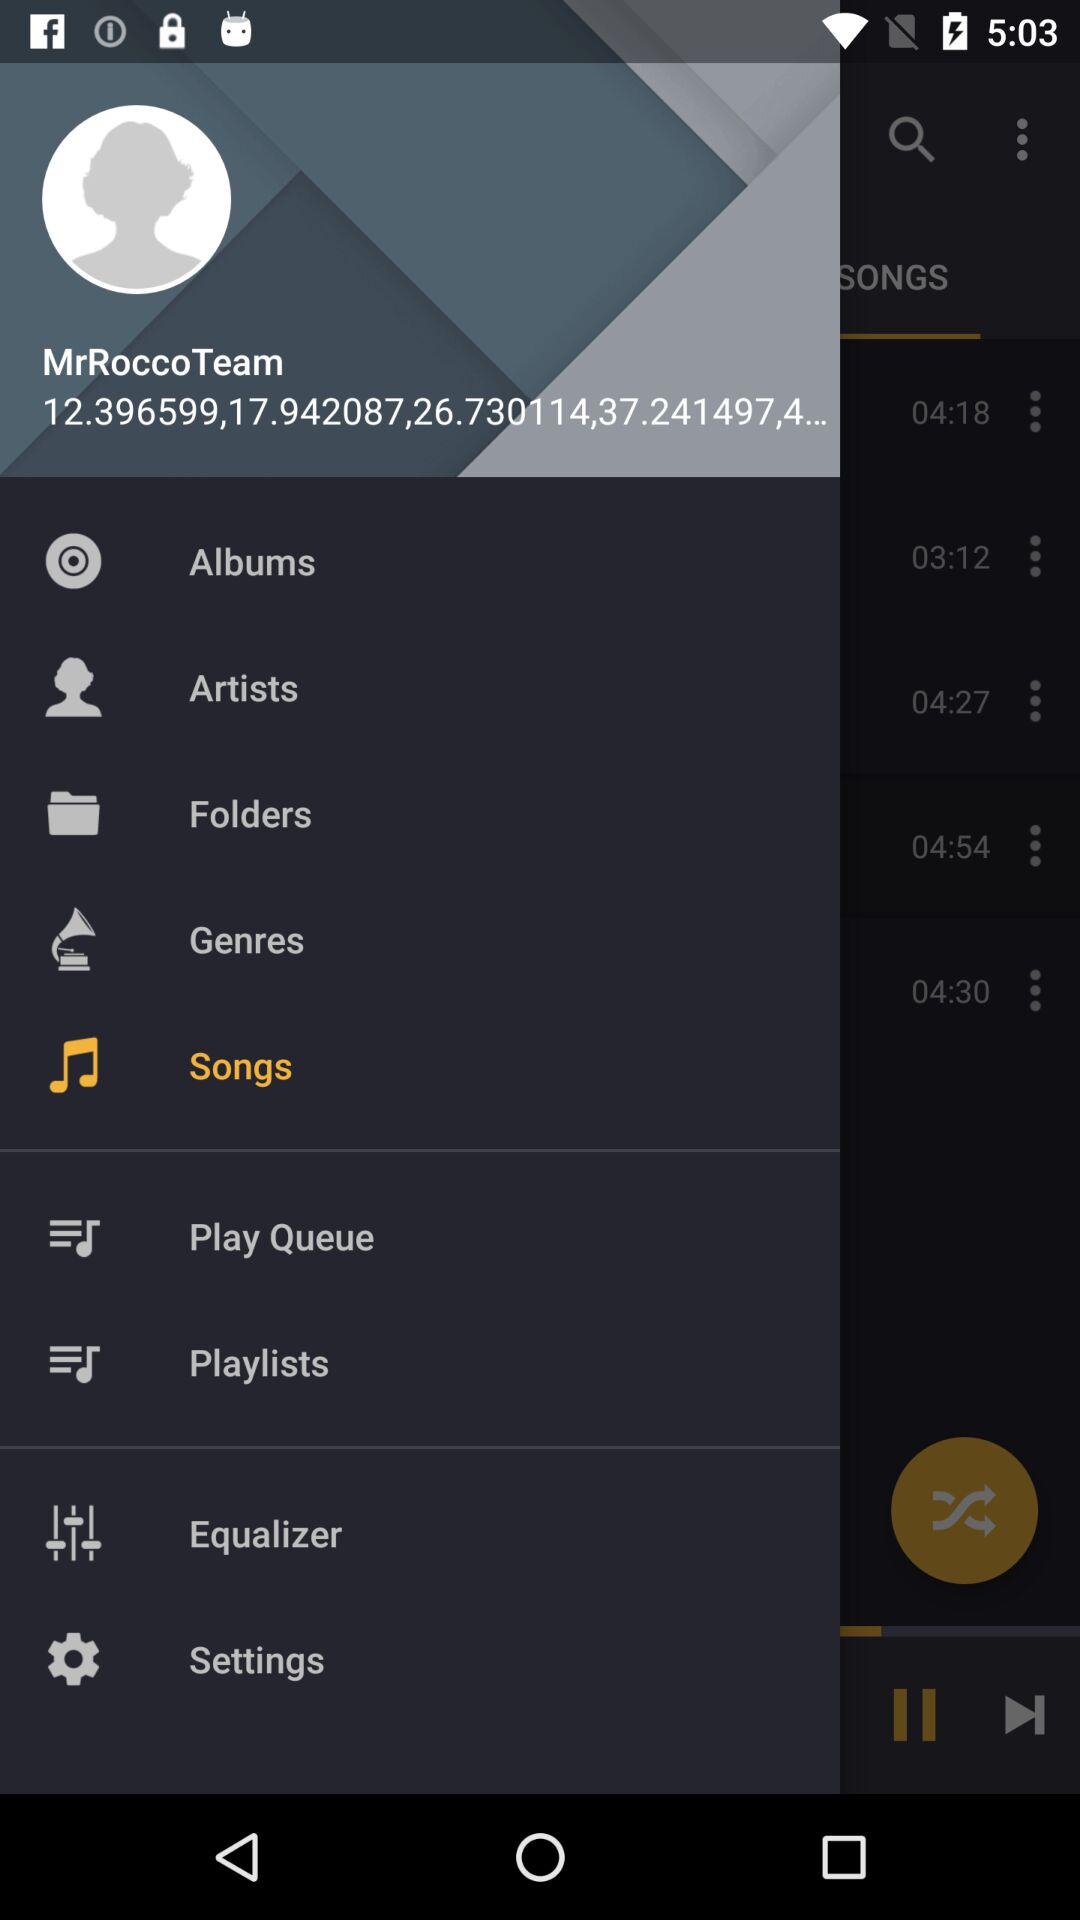What is the username? The username is "MrRoccoTeam". 